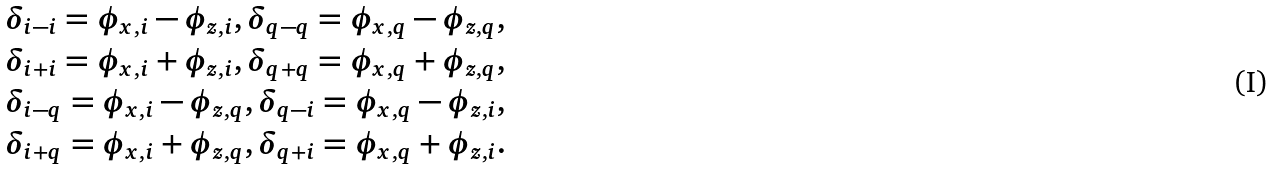<formula> <loc_0><loc_0><loc_500><loc_500>\delta _ { i - i } = \phi _ { x , i } - \phi _ { z , i } , \delta _ { q - q } = \phi _ { x , q } - \phi _ { z , q } , \\ \delta _ { i + i } = \phi _ { x , i } + \phi _ { z , i } , \delta _ { q + q } = \phi _ { x , q } + \phi _ { z , q } , \\ \delta _ { i - q } = \phi _ { x , i } - \phi _ { z , q } , \delta _ { q - i } = \phi _ { x , q } - \phi _ { z , i } , \\ \delta _ { i + q } = \phi _ { x , i } + \phi _ { z , q } , \delta _ { q + i } = \phi _ { x , q } + \phi _ { z , i } .</formula> 